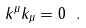Convert formula to latex. <formula><loc_0><loc_0><loc_500><loc_500>k ^ { \mu } k _ { \mu } = 0 \ .</formula> 